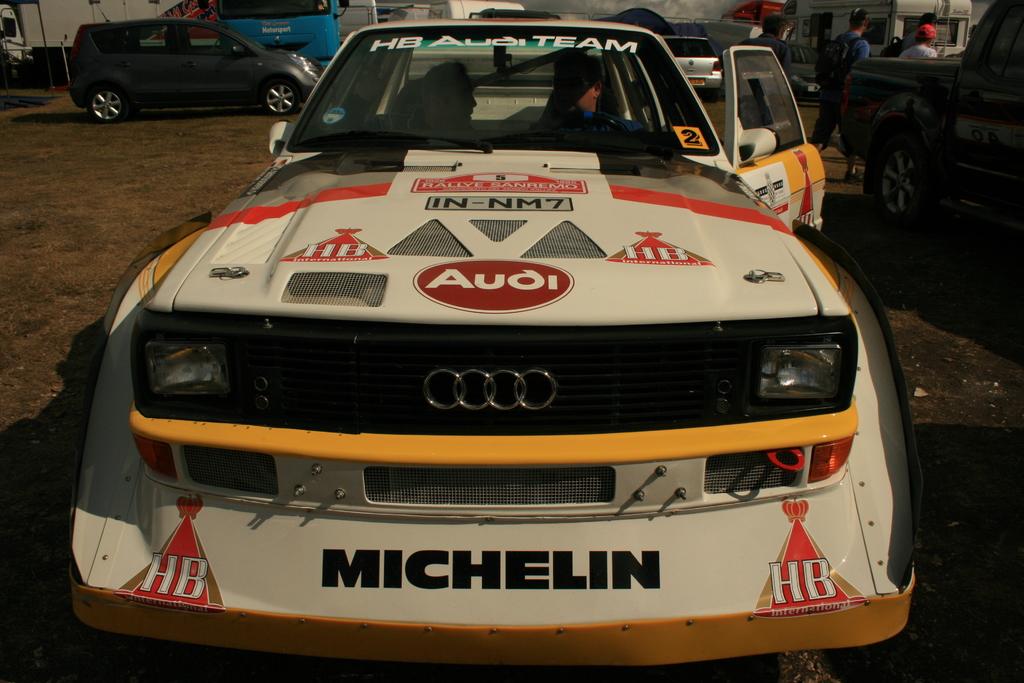What brand is on the front of the car?
Offer a terse response. Michelin. What is this car used for?
Provide a succinct answer. Racing. 